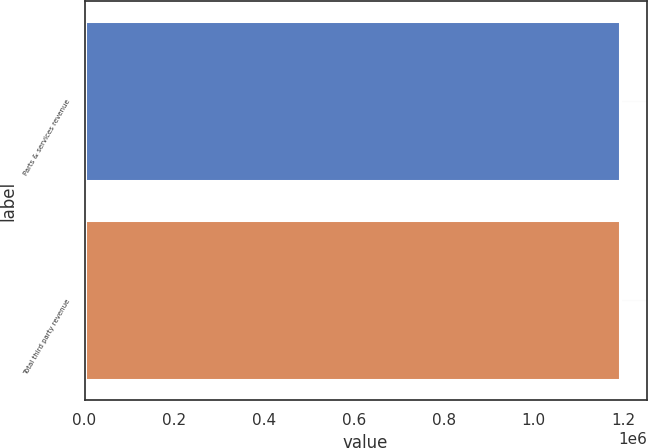<chart> <loc_0><loc_0><loc_500><loc_500><bar_chart><fcel>Parts & services revenue<fcel>Total third party revenue<nl><fcel>1.19266e+06<fcel>1.19266e+06<nl></chart> 